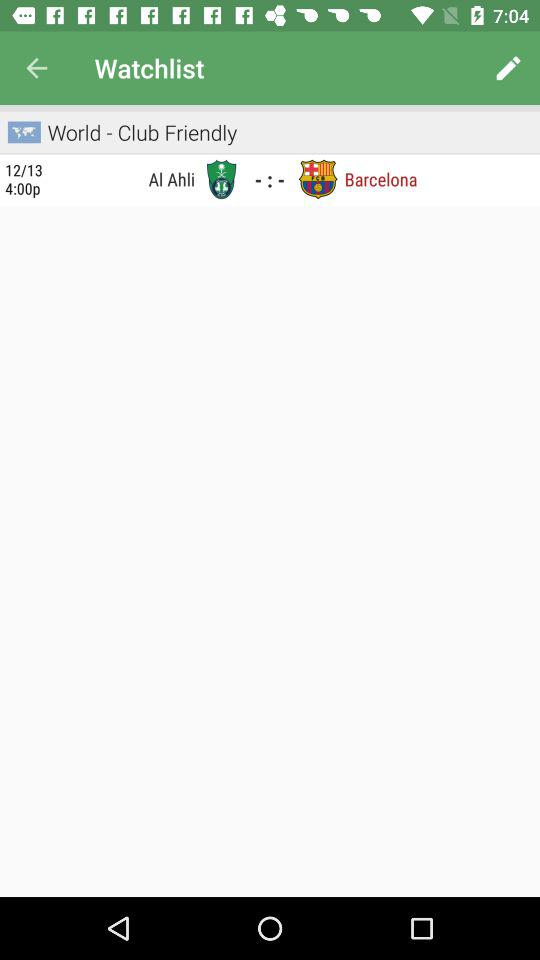How many teams are playing in the match?
Answer the question using a single word or phrase. 2 